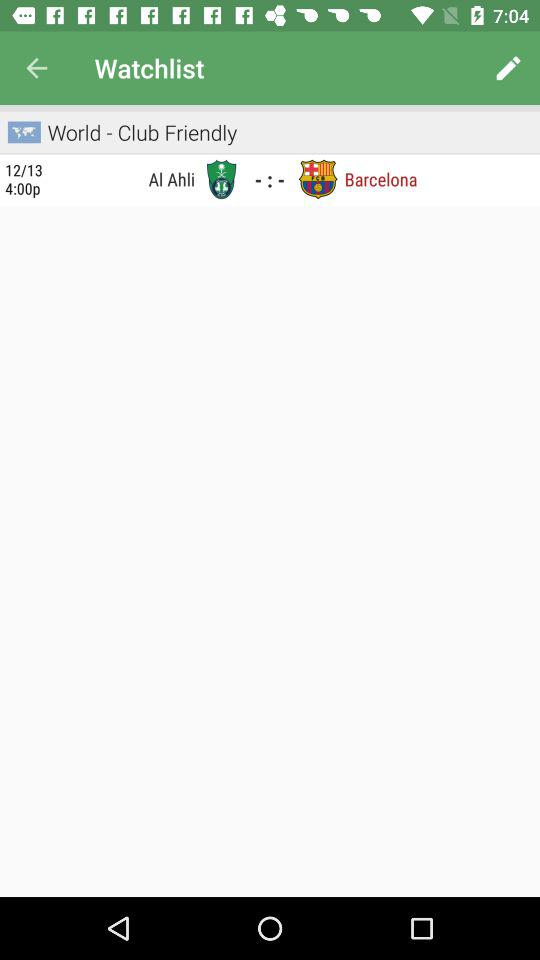How many teams are playing in the match?
Answer the question using a single word or phrase. 2 